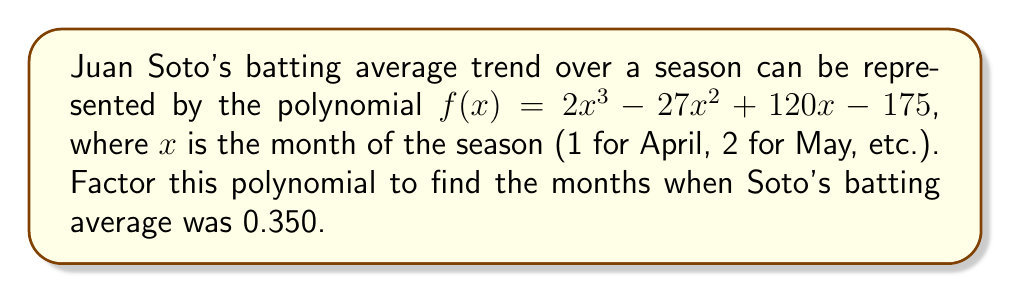Can you answer this question? To solve this problem, we need to factor the polynomial $f(x) = 2x^3 - 27x^2 + 120x - 175$ and find the roots that correspond to a batting average of 0.350.

Step 1: Set up the equation
$f(x) = 0.350$ when Soto's batting average is 0.350
$2x^3 - 27x^2 + 120x - 175 = 0.350$

Step 2: Subtract 0.350 from both sides
$2x^3 - 27x^2 + 120x - 175.350 = 0$

Step 3: Multiply all terms by 2 to eliminate fractions
$4x^3 - 54x^2 + 240x - 350.7 = 0$

Step 4: Factor out the greatest common factor (GCF)
$0.1(40x^3 - 540x^2 + 2400x - 3507) = 0$

Step 5: Use the rational root theorem to find potential roots
Potential roots: $\pm 1, \pm 3, \pm 9$

Step 6: Test these roots and find that $x = 3$ and $x = 9$ are roots

Step 7: Factor out $(x - 3)(x - 9)$
$0.1(x - 3)(x - 9)(40x - 39) = 0$

Step 8: Solve the linear factor
$40x - 39 = 0$
$x = \frac{39}{40} = 0.975$

Therefore, the factors are $(x - 3)$, $(x - 9)$, and $(x - 0.975)$, corresponding to months 3 (June), 9 (December, which is outside the baseball season), and between months 0 and 1 (before the season starts).
Answer: $f(x) = 0.1(x - 3)(x - 9)(40x - 39)$; Soto's batting average was 0.350 in June (month 3). 